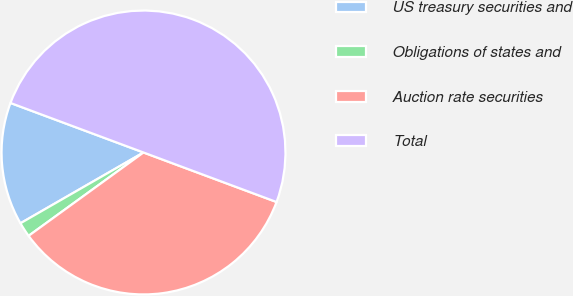<chart> <loc_0><loc_0><loc_500><loc_500><pie_chart><fcel>US treasury securities and<fcel>Obligations of states and<fcel>Auction rate securities<fcel>Total<nl><fcel>13.98%<fcel>1.68%<fcel>34.34%<fcel>50.0%<nl></chart> 